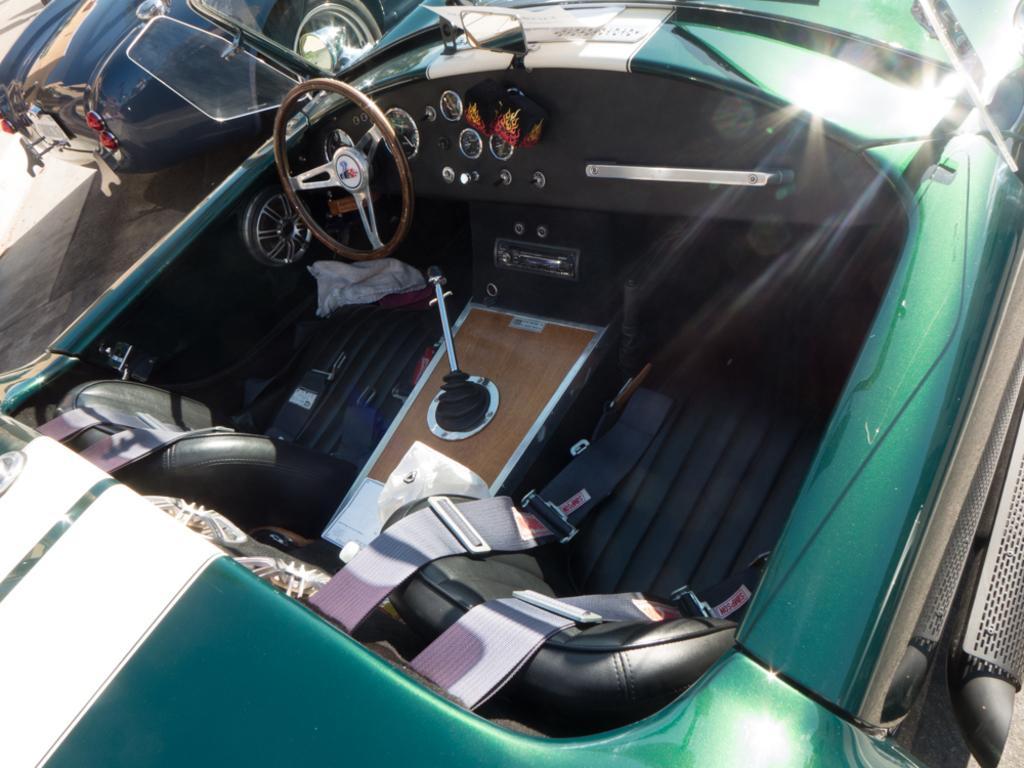Can you describe this image briefly? In this picture we can see two vehicles on the road, here we can see a steering, speedometers, seats, seat belts, mirrors and some objects. 